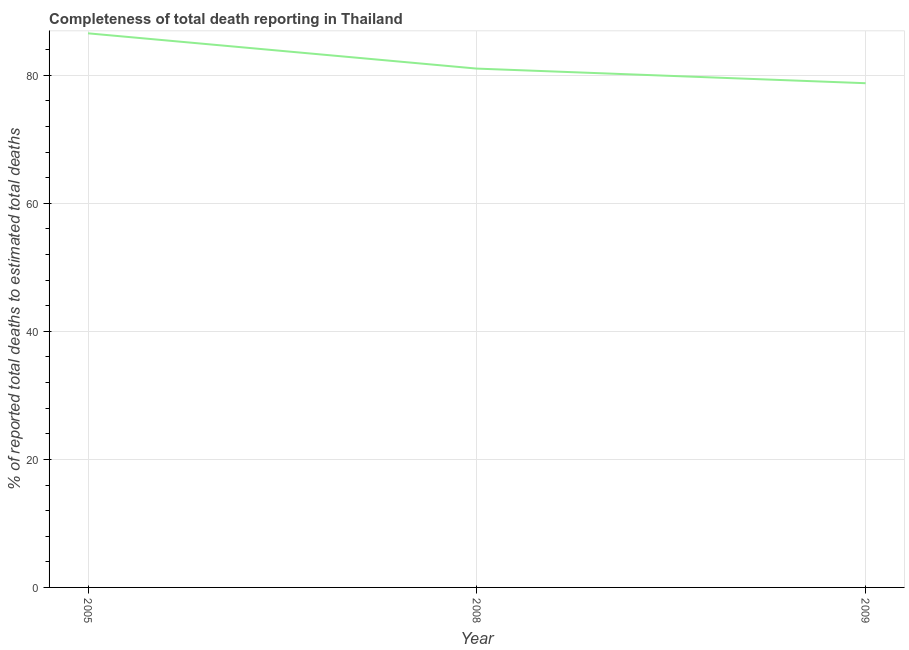What is the completeness of total death reports in 2008?
Offer a terse response. 81.05. Across all years, what is the maximum completeness of total death reports?
Provide a succinct answer. 86.56. Across all years, what is the minimum completeness of total death reports?
Provide a succinct answer. 78.77. In which year was the completeness of total death reports maximum?
Provide a succinct answer. 2005. What is the sum of the completeness of total death reports?
Provide a succinct answer. 246.37. What is the difference between the completeness of total death reports in 2008 and 2009?
Your response must be concise. 2.28. What is the average completeness of total death reports per year?
Your response must be concise. 82.12. What is the median completeness of total death reports?
Your answer should be very brief. 81.05. In how many years, is the completeness of total death reports greater than 48 %?
Provide a succinct answer. 3. What is the ratio of the completeness of total death reports in 2008 to that in 2009?
Your answer should be compact. 1.03. Is the completeness of total death reports in 2008 less than that in 2009?
Provide a succinct answer. No. Is the difference between the completeness of total death reports in 2005 and 2009 greater than the difference between any two years?
Provide a short and direct response. Yes. What is the difference between the highest and the second highest completeness of total death reports?
Your answer should be compact. 5.51. Is the sum of the completeness of total death reports in 2005 and 2009 greater than the maximum completeness of total death reports across all years?
Provide a succinct answer. Yes. What is the difference between the highest and the lowest completeness of total death reports?
Offer a very short reply. 7.79. Does the completeness of total death reports monotonically increase over the years?
Keep it short and to the point. No. How many lines are there?
Ensure brevity in your answer.  1. How many years are there in the graph?
Provide a short and direct response. 3. Are the values on the major ticks of Y-axis written in scientific E-notation?
Ensure brevity in your answer.  No. What is the title of the graph?
Provide a short and direct response. Completeness of total death reporting in Thailand. What is the label or title of the X-axis?
Make the answer very short. Year. What is the label or title of the Y-axis?
Offer a terse response. % of reported total deaths to estimated total deaths. What is the % of reported total deaths to estimated total deaths of 2005?
Make the answer very short. 86.56. What is the % of reported total deaths to estimated total deaths in 2008?
Give a very brief answer. 81.05. What is the % of reported total deaths to estimated total deaths of 2009?
Your answer should be compact. 78.77. What is the difference between the % of reported total deaths to estimated total deaths in 2005 and 2008?
Offer a terse response. 5.51. What is the difference between the % of reported total deaths to estimated total deaths in 2005 and 2009?
Provide a succinct answer. 7.79. What is the difference between the % of reported total deaths to estimated total deaths in 2008 and 2009?
Your answer should be very brief. 2.28. What is the ratio of the % of reported total deaths to estimated total deaths in 2005 to that in 2008?
Give a very brief answer. 1.07. What is the ratio of the % of reported total deaths to estimated total deaths in 2005 to that in 2009?
Your response must be concise. 1.1. What is the ratio of the % of reported total deaths to estimated total deaths in 2008 to that in 2009?
Offer a very short reply. 1.03. 